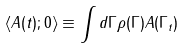<formula> <loc_0><loc_0><loc_500><loc_500>\langle A ( t ) ; 0 \rangle \equiv \int d \Gamma \rho ( \Gamma ) A ( \Gamma _ { t } )</formula> 